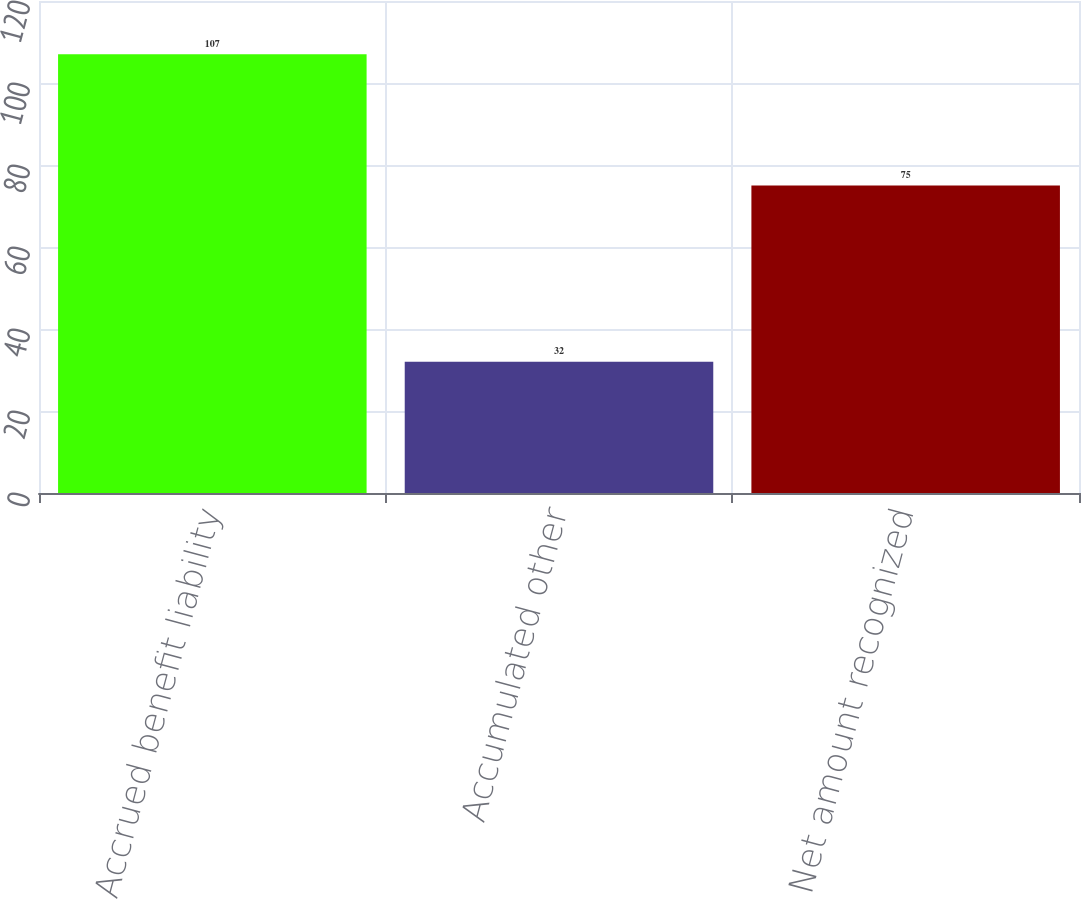Convert chart to OTSL. <chart><loc_0><loc_0><loc_500><loc_500><bar_chart><fcel>Accrued benefit liability<fcel>Accumulated other<fcel>Net amount recognized<nl><fcel>107<fcel>32<fcel>75<nl></chart> 